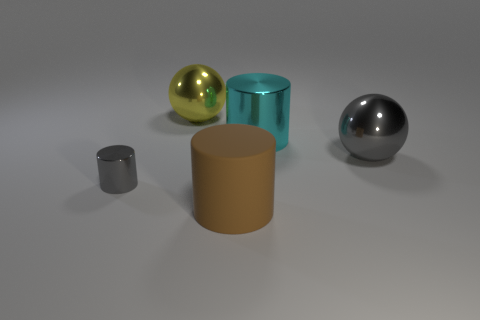Add 1 brown things. How many objects exist? 6 Subtract all balls. How many objects are left? 3 Subtract all tiny yellow rubber cylinders. Subtract all gray objects. How many objects are left? 3 Add 2 big brown cylinders. How many big brown cylinders are left? 3 Add 1 large yellow things. How many large yellow things exist? 2 Subtract 0 gray cubes. How many objects are left? 5 